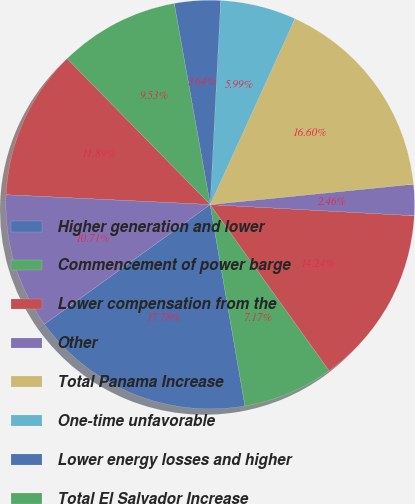Convert chart to OTSL. <chart><loc_0><loc_0><loc_500><loc_500><pie_chart><fcel>Higher generation and lower<fcel>Commencement of power barge<fcel>Lower compensation from the<fcel>Other<fcel>Total Panama Increase<fcel>One-time unfavorable<fcel>Lower energy losses and higher<fcel>Total El Salvador Increase<fcel>Lower commodity prices<fcel>Lower availability<nl><fcel>17.78%<fcel>7.17%<fcel>14.24%<fcel>2.46%<fcel>16.6%<fcel>5.99%<fcel>3.64%<fcel>9.53%<fcel>11.89%<fcel>10.71%<nl></chart> 